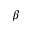<formula> <loc_0><loc_0><loc_500><loc_500>\beta</formula> 